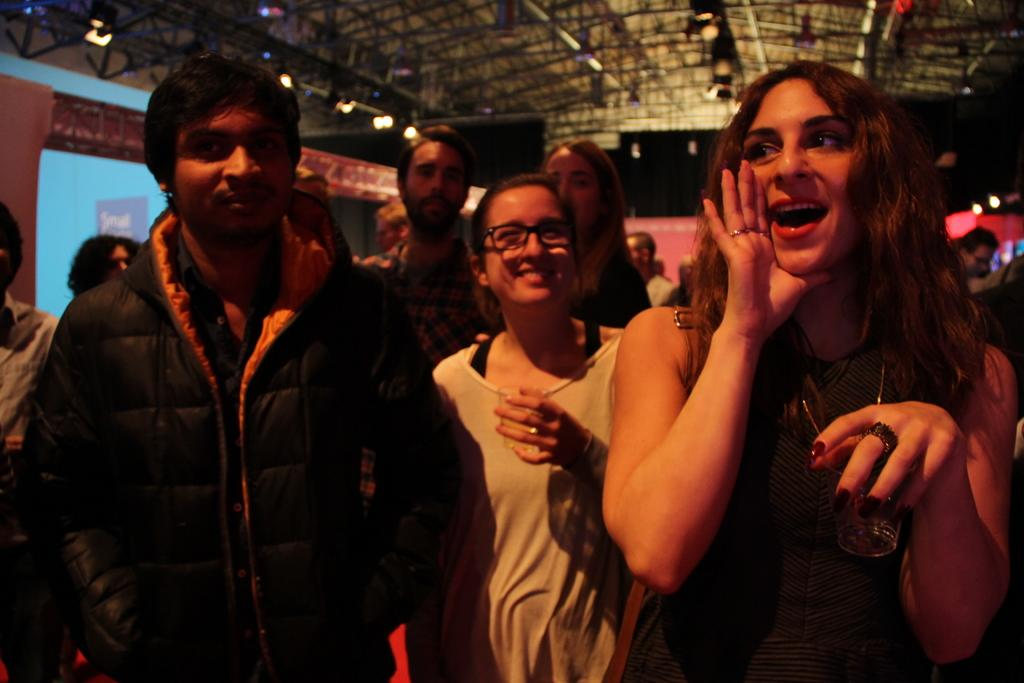How many people are in the image? There are people in the image, but the exact number is not specified. What are two persons doing with their hands? Two persons are holding a glass in their hands. What can be seen attached to the ceiling in the image? There are lights attached to the ceiling in the image. What flavor of government is depicted in the image? There is no reference to any form of government in the image, so it is not possible to determine its flavor. 